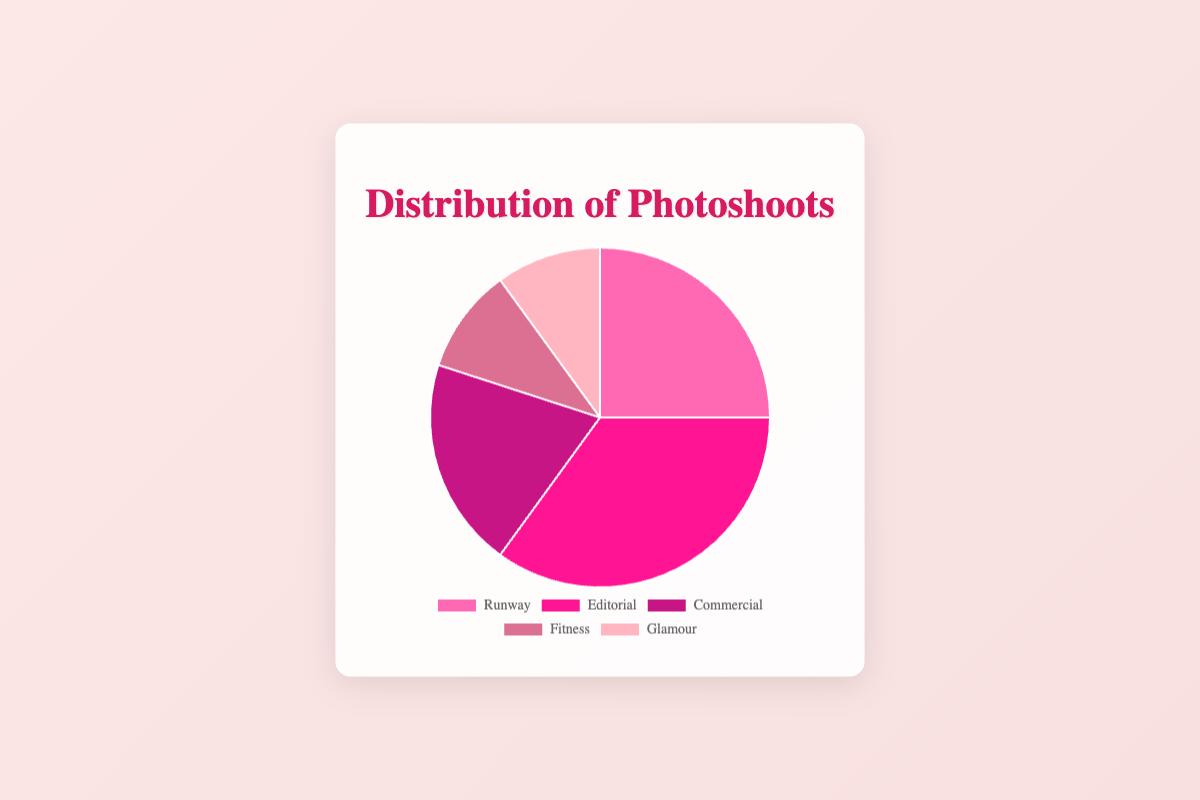Which type of photoshoot has the highest distribution? From the pie chart, Editorial has the highest percentage of distribution at 35%.
Answer: Editorial Which two types of photoshoots have an equal distribution? The pie chart shows that both Fitness and Glamour photoshoots have 10% distribution each, making them equal.
Answer: Fitness and Glamour What is the total percentage of non-editorial photoshoots? Summing the percentages of Runway (25%), Commercial (20%), Fitness (10%), and Glamour (10%) equals 65%.
Answer: 65% Which photoshoot type is the second most common? From the pie chart, the second highest percentage after Editorial (35%) is Runway with 25%.
Answer: Runway How much larger is the Editorial photoshoot distribution compared to the Fitness photoshoot distribution? Editorial has 35% distribution while Fitness has 10%, making the difference 35% - 10% = 25%.
Answer: 25% What is the combined percentage of the two least common types of photoshoots? The least common types of photoshoots are Fitness and Glamour, both with 10% each. Their combined percentage is 10% + 10% = 20%.
Answer: 20% Which photoshoot type has a distribution that is double that of Fitness? Runway has a distribution of 25%, which is more than double 10%, but Commercial with a distribution of 20% is exactly double that of Fitness (10%).
Answer: Commercial What percentage of the total photoshoots are either Runway or Glamour? Summing the percentages of Runway (25%) and Glamour (10%) results in 25% + 10% = 35%.
Answer: 35% If the total number of photoshoots is 1000, how many more Editorial photoshoots are there than Fitness photoshoots? Editorial has 35% of the photoshoots, which means 35% of 1000 is 350. Fitness has 10% of the photoshoots, meaning 10% of 1000 is 100. The difference is 350 - 100 = 250.
Answer: 250 What percentage of photoshoots are either Commercial or Runway but not Editorial? The distribution percentages for Commercial and Runway are 20% and 25%, respectively. Summing these gives 20% + 25% = 45%.
Answer: 45% 